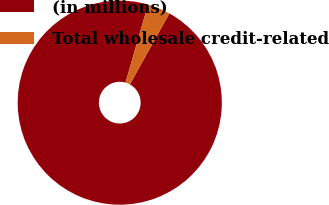<chart> <loc_0><loc_0><loc_500><loc_500><pie_chart><fcel>(in millions)<fcel>Total wholesale credit-related<nl><fcel>96.4%<fcel>3.6%<nl></chart> 